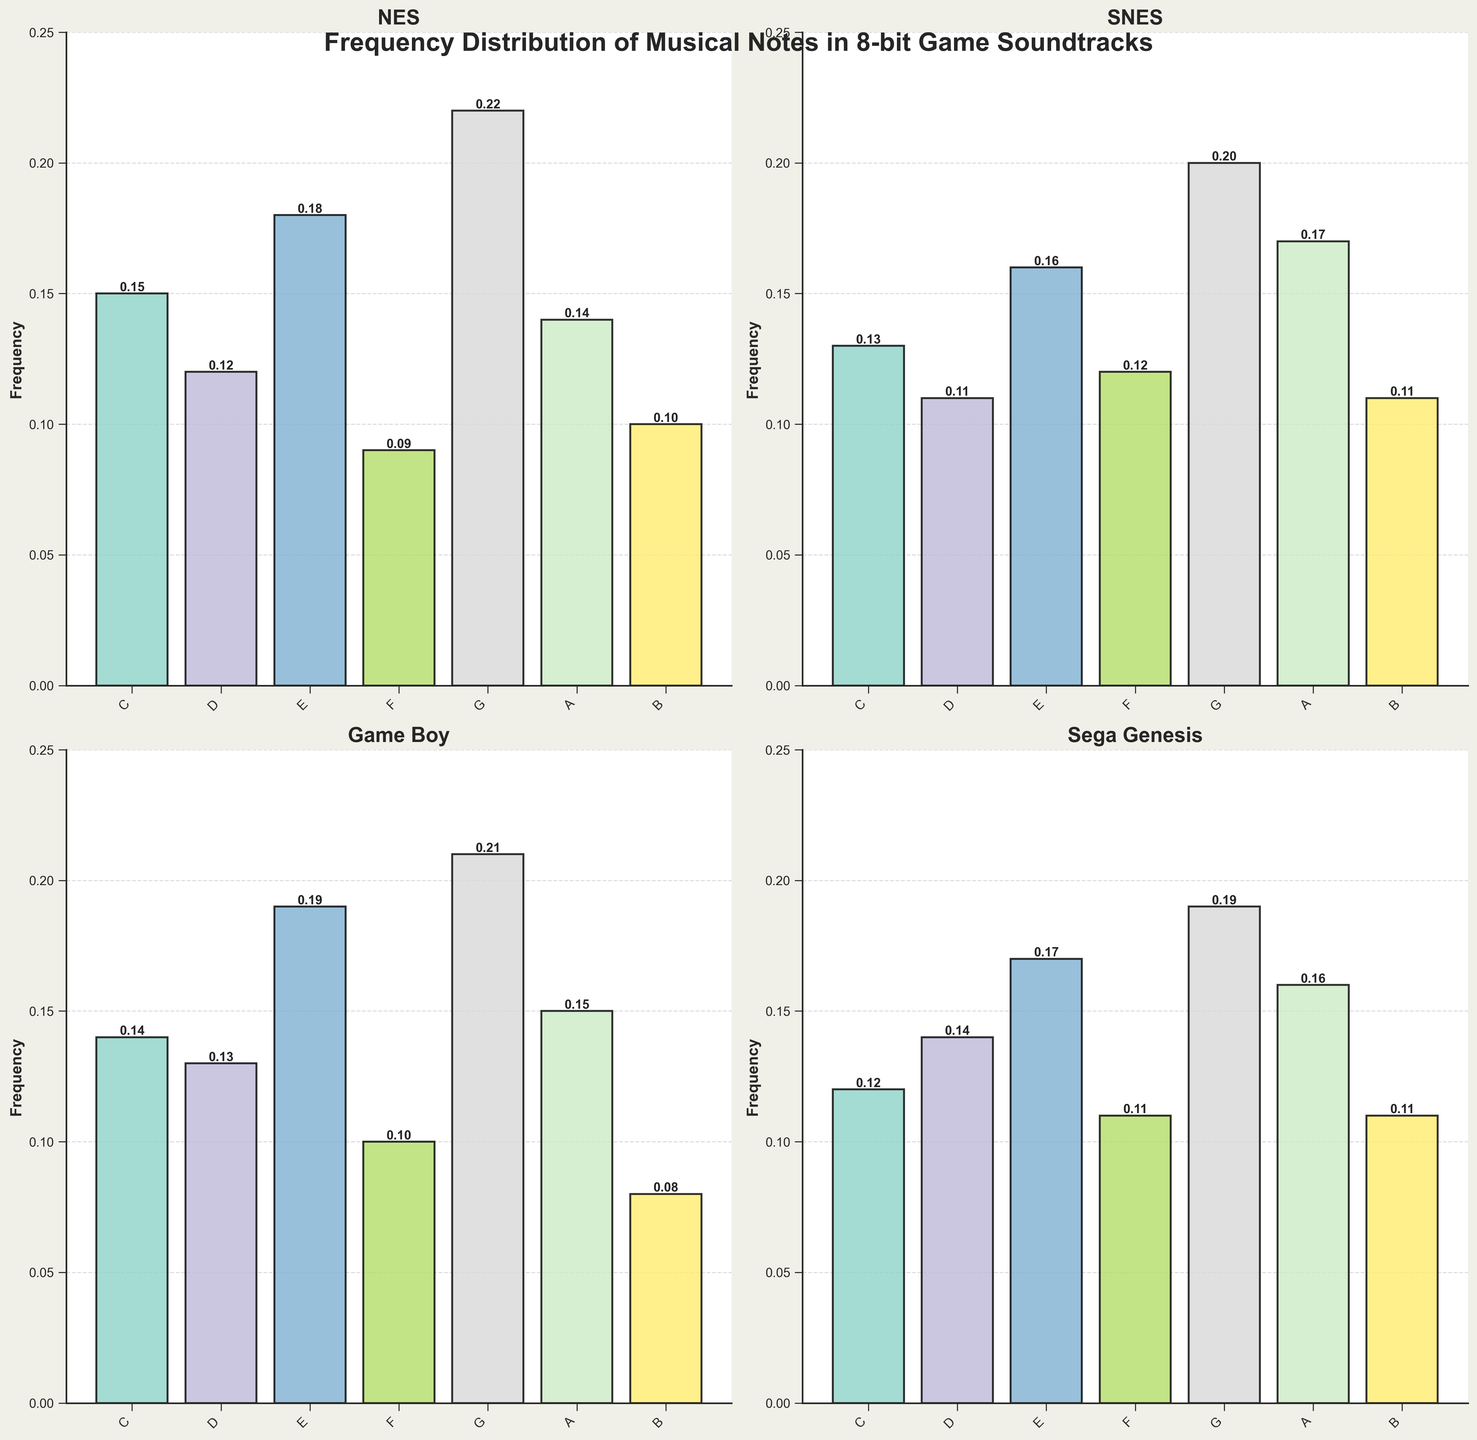What is the highest frequency of note G in any console generation? From the subplots, detect the bar representing note G for each console generation. Compare the heights and identify the tallest bar. The Sega Genesis has the highest note G frequency at approximately 0.19.
Answer: 0.22 Which console generation has the lowest frequency of note B? Identify the bars corresponding to note B in all subplots and compare their heights. The Game Boy shows the lowest frequency for note B at 0.08.
Answer: Game Boy What is the average frequency of note E across all console generations? Add up the frequencies of note E from all consoles: 0.18 (NES) + 0.16 (SNES) + 0.19 (Game Boy) + 0.17 (Sega Genesis) = 0.70. Divide by 4 (number of console generations): 0.70 / 4 = 0.175.
Answer: 0.175 Which console generation exhibits the most uniform distribution of note frequencies? Evaluate the heights of the bars within each subplot to check for uniformity. The SNES subplot shows the most uniform distribution as the heights of the bars are more similar to each other.
Answer: SNES What is the total frequency of notes C and F combined in the NES console? Add the frequencies of notes C and F in the NES subplot: 0.15 (C) + 0.09 (F) = 0.24.
Answer: 0.24 In which console generation is note A more frequent than note D? Compare the heights of the bars representing notes A and D for each console plot. Both SNES (0.17 vs 0.11), Game Boy (0.15 vs 0.13), and Sega Genesis (0.16 vs 0.14) have note A being more frequent than note D.
Answer: SNES, Game Boy, Sega Genesis What is the combined frequency of all notes in the Game Boy console? Sum all the bar heights within the Game Boy subplot: 0.14 (C) + 0.13 (D) + 0.19 (E) + 0.10 (F) + 0.21 (G) + 0.15 (A) + 0.08 (B) = 1.00.
Answer: 1.00 Which note has the highest average frequency across all console generations? For each note, calculate the average frequency across the consoles and then compare. Note G has the highest average: (0.22 + 0.20 + 0.21 + 0.19) / 4 = 0.205.
Answer: G In which console generation is the difference between the highest and lowest note frequencies the greatest? Calculate the range (maximum frequency - minimum frequency) for each subplot: NES (0.22 - 0.09 = 0.13), SNES (0.20 - 0.11 = 0.09), Game Boy (0.21 - 0.08 = 0.13), Sega Genesis (0.19 - 0.11 = 0.08). The range is the greatest for NES and Game Boy at 0.13.
Answer: NES and Game Boy 